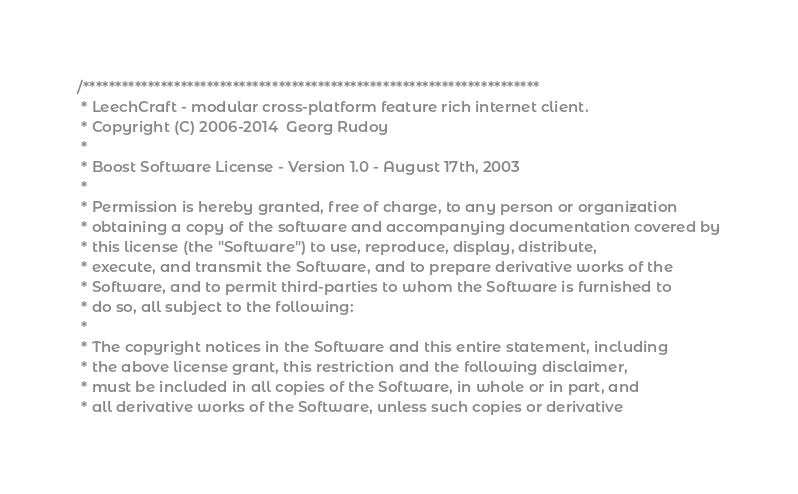Convert code to text. <code><loc_0><loc_0><loc_500><loc_500><_C_>/**********************************************************************
 * LeechCraft - modular cross-platform feature rich internet client.
 * Copyright (C) 2006-2014  Georg Rudoy
 *
 * Boost Software License - Version 1.0 - August 17th, 2003
 *
 * Permission is hereby granted, free of charge, to any person or organization
 * obtaining a copy of the software and accompanying documentation covered by
 * this license (the "Software") to use, reproduce, display, distribute,
 * execute, and transmit the Software, and to prepare derivative works of the
 * Software, and to permit third-parties to whom the Software is furnished to
 * do so, all subject to the following:
 *
 * The copyright notices in the Software and this entire statement, including
 * the above license grant, this restriction and the following disclaimer,
 * must be included in all copies of the Software, in whole or in part, and
 * all derivative works of the Software, unless such copies or derivative</code> 